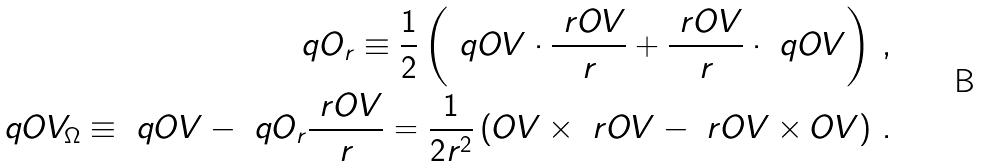<formula> <loc_0><loc_0><loc_500><loc_500>\ q O _ { r } \equiv \frac { 1 } { 2 } \left ( \ q O V \cdot \frac { \ r O V } { r } + \frac { \ r O V } { r } \cdot \ q O V \right ) \, , \\ \ q O V _ { \Omega } \equiv \ q O V - \ q O _ { r } \frac { \ r O V } { r } = \frac { 1 } { 2 r ^ { 2 } } \left ( \L O V \times \ r O V - \ r O V \times \L O V \right ) \, .</formula> 